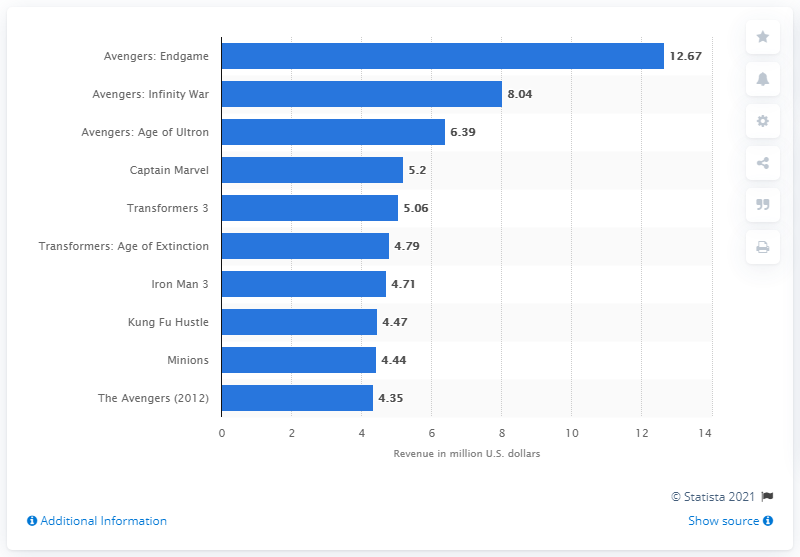Identify some key points in this picture. By the end of its opening weekend, the movie "Avengers: Endgame" earned a total of $12.67 million. 